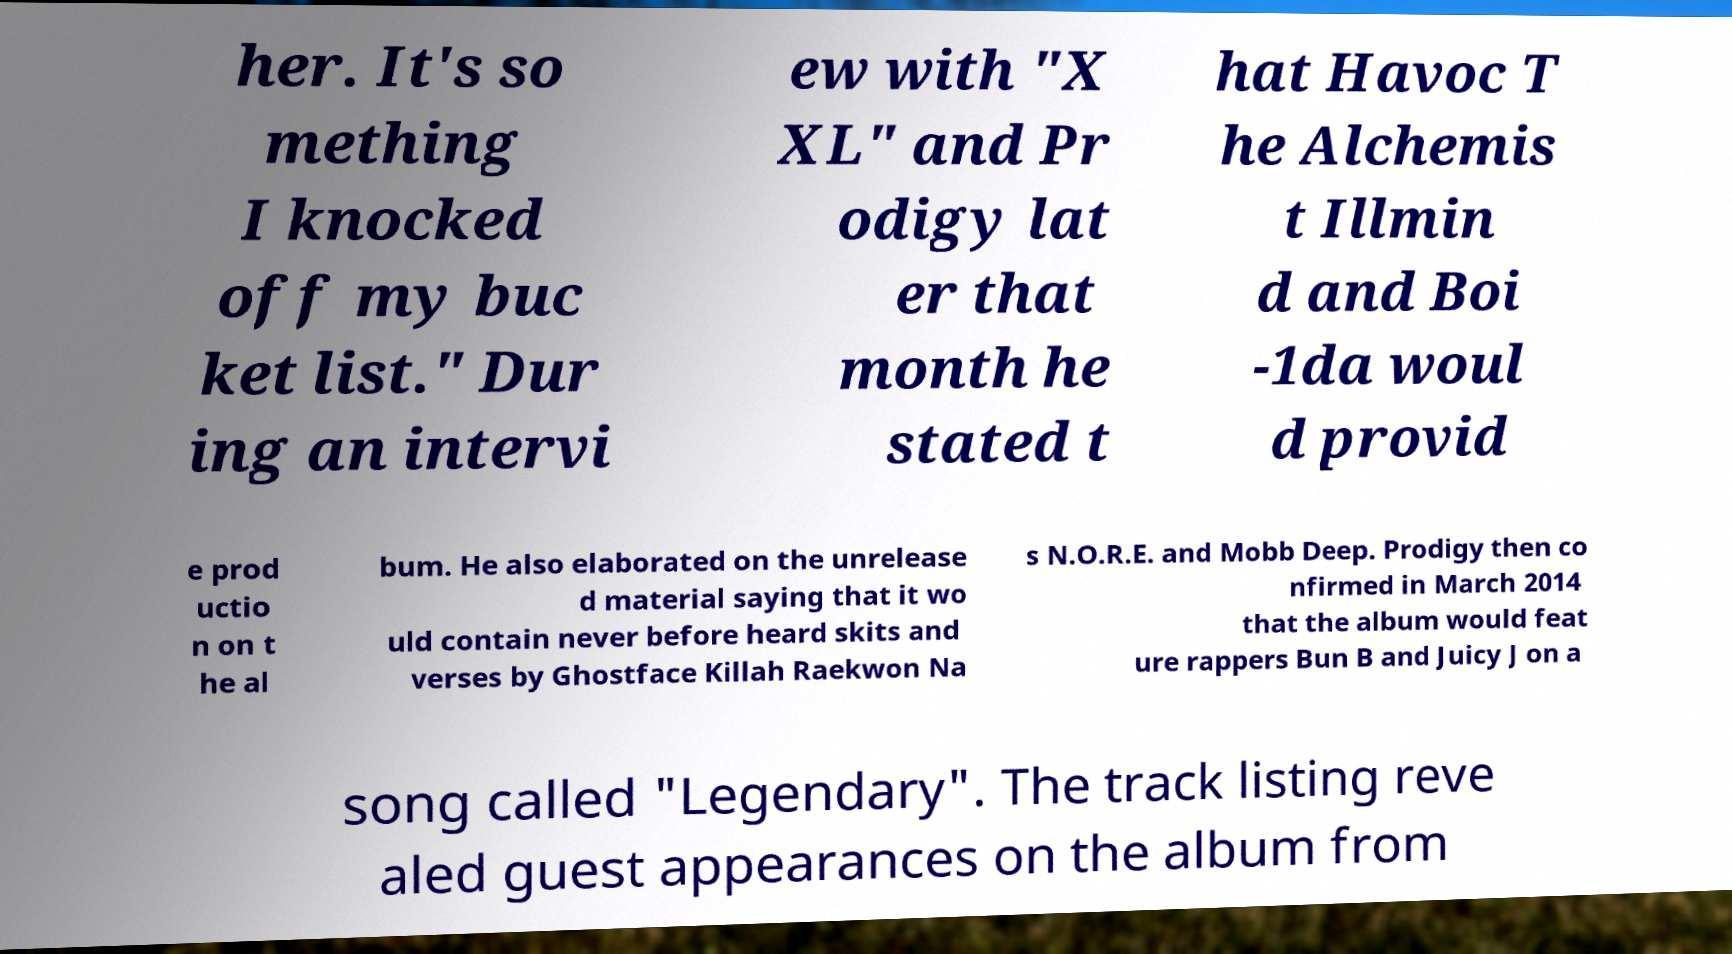What messages or text are displayed in this image? I need them in a readable, typed format. her. It's so mething I knocked off my buc ket list." Dur ing an intervi ew with "X XL" and Pr odigy lat er that month he stated t hat Havoc T he Alchemis t Illmin d and Boi -1da woul d provid e prod uctio n on t he al bum. He also elaborated on the unrelease d material saying that it wo uld contain never before heard skits and verses by Ghostface Killah Raekwon Na s N.O.R.E. and Mobb Deep. Prodigy then co nfirmed in March 2014 that the album would feat ure rappers Bun B and Juicy J on a song called "Legendary". The track listing reve aled guest appearances on the album from 